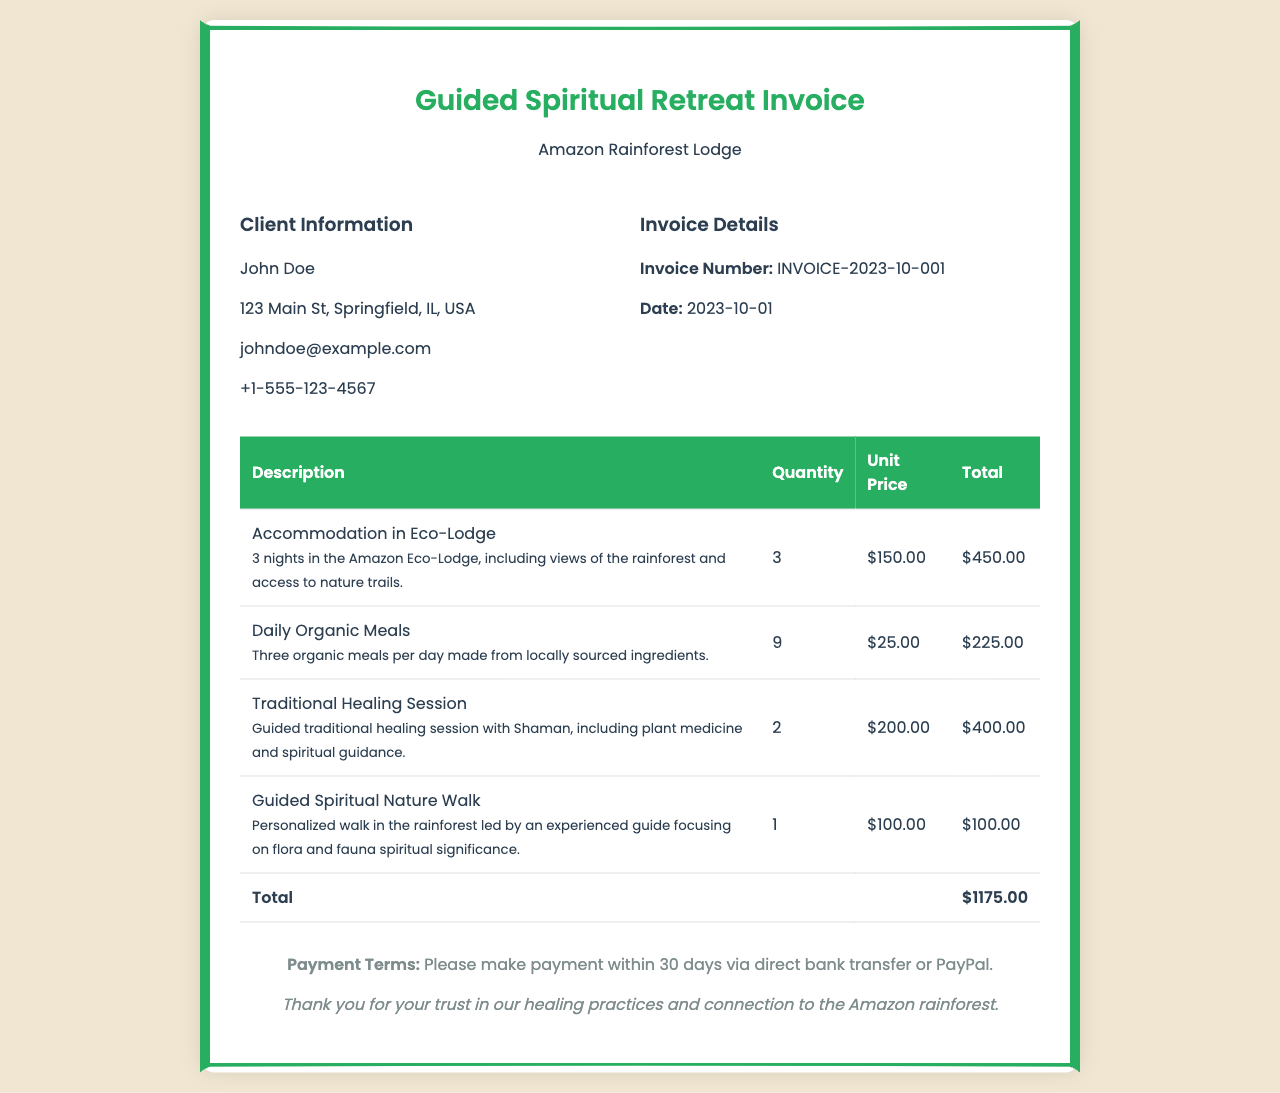What is the invoice number? The invoice number is a specific identifier for the invoice, found in the invoice details section.
Answer: INVOICE-2023-10-001 Who is the client? The client's name is given at the top of the client information section.
Answer: John Doe How many nights of accommodation are included? The number of nights is specified in the accommodation description on the invoice.
Answer: 3 What is the total amount due? The total amount due is listed at the bottom of the invoice in the total row.
Answer: $1175.00 What is the cost of one traditional healing session? The unit price for one traditional healing session is indicated in the table.
Answer: $200.00 How many organic meals are provided? The quantity of organic meals is mentioned separately in the meals section of the invoice.
Answer: 9 What is the date of the invoice? The date is mentioned in the invoice details section, specifying when the invoice was issued.
Answer: 2023-10-01 What type of retreat is being invoiced? The title of the invoice clearly states what type of service the document pertains to.
Answer: Guided Spiritual Retreat 